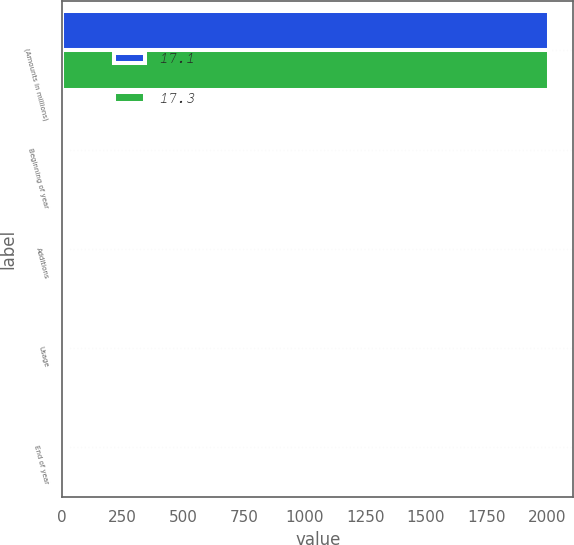Convert chart. <chart><loc_0><loc_0><loc_500><loc_500><stacked_bar_chart><ecel><fcel>(Amounts in millions)<fcel>Beginning of year<fcel>Additions<fcel>Usage<fcel>End of year<nl><fcel>17.1<fcel>2007<fcel>17.3<fcel>14<fcel>14.2<fcel>17.1<nl><fcel>17.3<fcel>2006<fcel>16.8<fcel>15.5<fcel>15<fcel>17.3<nl></chart> 